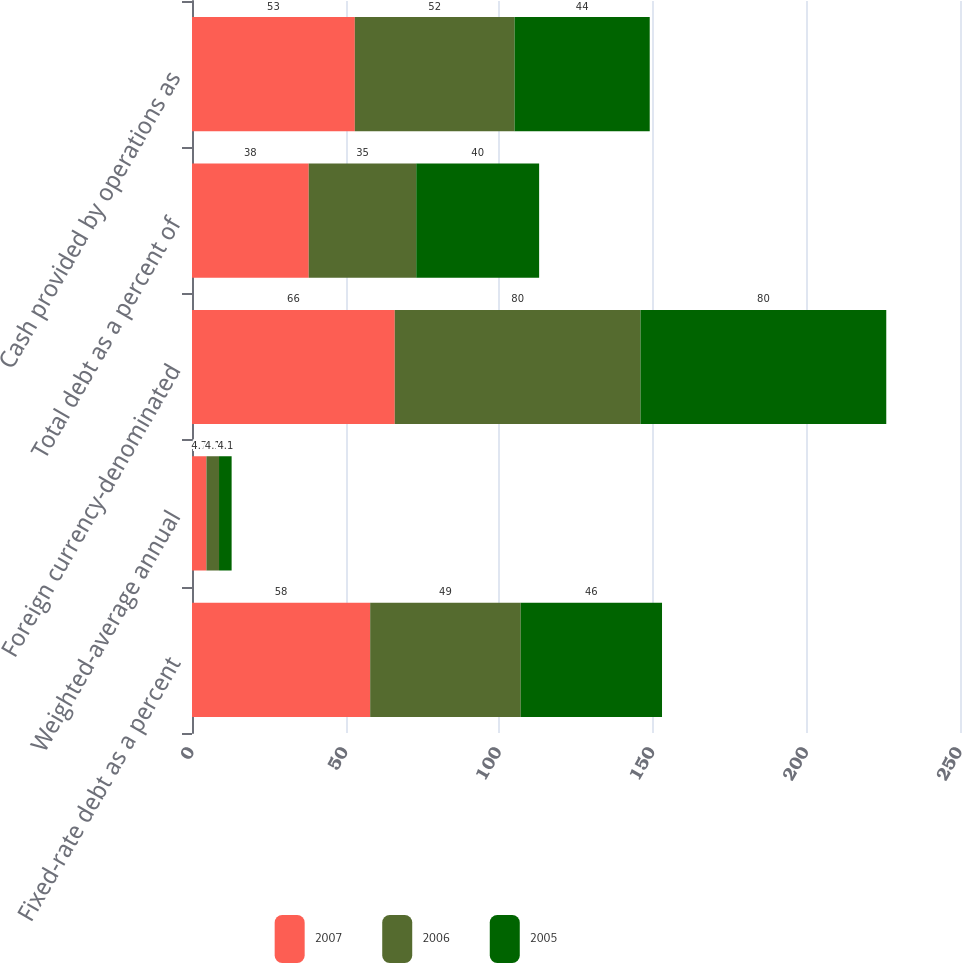Convert chart to OTSL. <chart><loc_0><loc_0><loc_500><loc_500><stacked_bar_chart><ecel><fcel>Fixed-rate debt as a percent<fcel>Weighted-average annual<fcel>Foreign currency-denominated<fcel>Total debt as a percent of<fcel>Cash provided by operations as<nl><fcel>2007<fcel>58<fcel>4.7<fcel>66<fcel>38<fcel>53<nl><fcel>2006<fcel>49<fcel>4.1<fcel>80<fcel>35<fcel>52<nl><fcel>2005<fcel>46<fcel>4.1<fcel>80<fcel>40<fcel>44<nl></chart> 